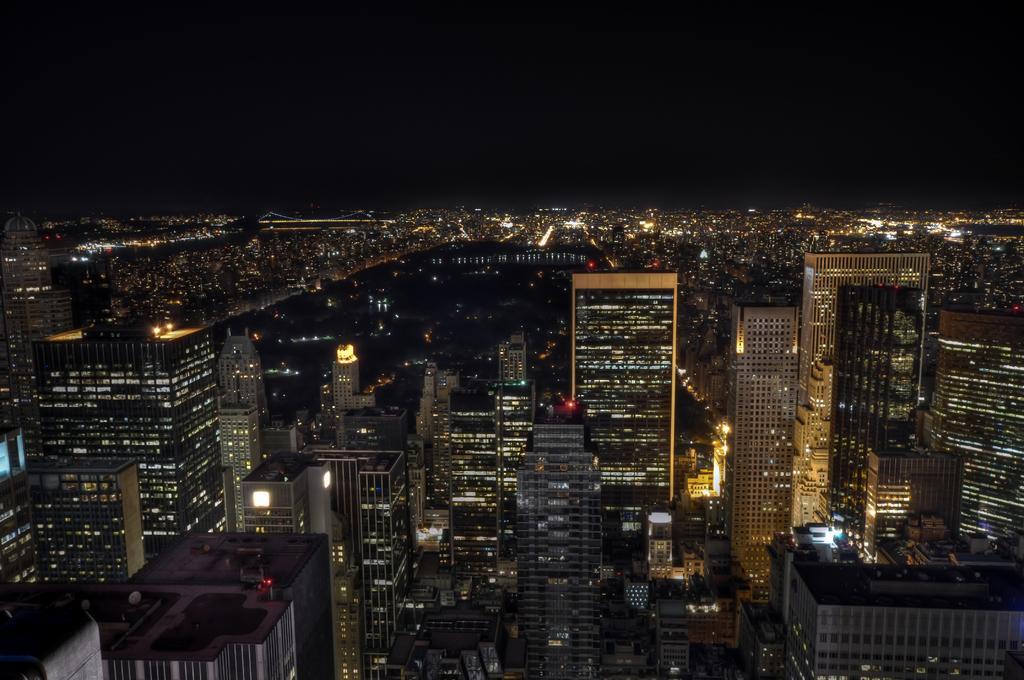Can you describe this image briefly? This is a top view image of a city, in this image we can see the buildings. 